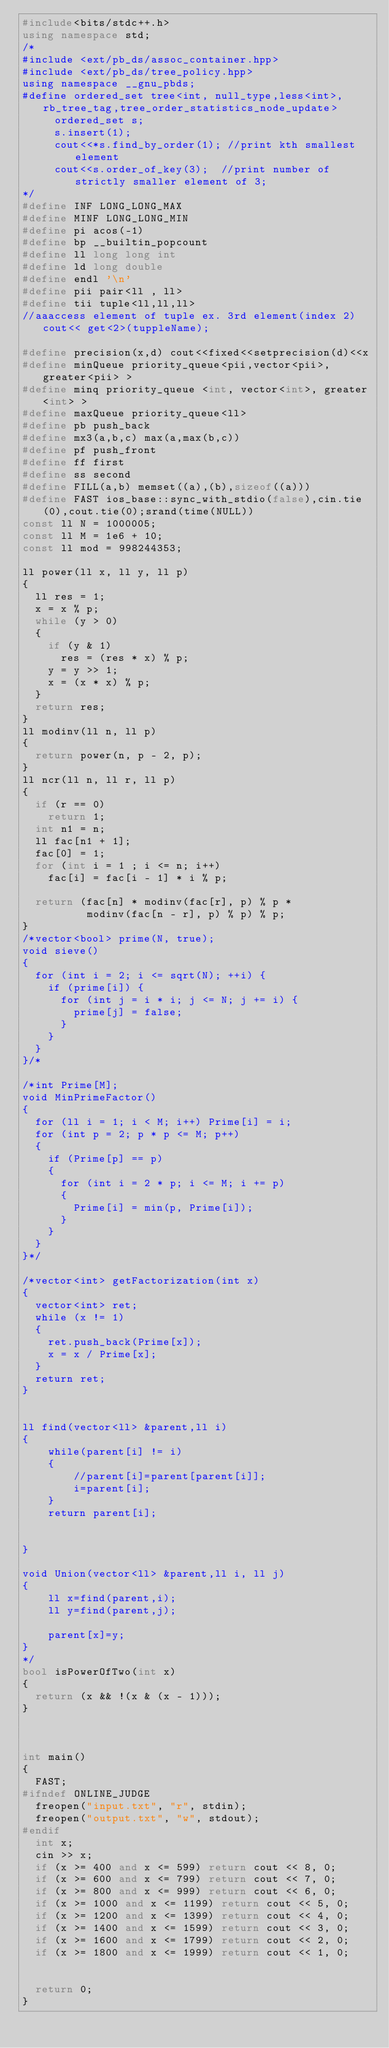Convert code to text. <code><loc_0><loc_0><loc_500><loc_500><_C++_>#include<bits/stdc++.h>
using namespace std;
/*
#include <ext/pb_ds/assoc_container.hpp>
#include <ext/pb_ds/tree_policy.hpp>
using namespace __gnu_pbds;
#define ordered_set tree<int, null_type,less<int>, rb_tree_tag,tree_order_statistics_node_update>
     ordered_set s;
     s.insert(1);
     cout<<*s.find_by_order(1); //print kth smallest element
     cout<<s.order_of_key(3);  //print number of strictly smaller element of 3;
*/
#define INF LONG_LONG_MAX
#define MINF LONG_LONG_MIN
#define pi acos(-1)
#define bp __builtin_popcount
#define ll long long int
#define ld long double
#define endl '\n'
#define pii pair<ll , ll>
#define tii tuple<ll,ll,ll>
//aaaccess element of tuple ex. 3rd element(index 2) cout<< get<2>(tuppleName);

#define precision(x,d) cout<<fixed<<setprecision(d)<<x
#define minQueue priority_queue<pii,vector<pii>,greater<pii> >
#define minq priority_queue <int, vector<int>, greater<int> >
#define maxQueue priority_queue<ll>
#define pb push_back
#define mx3(a,b,c) max(a,max(b,c))
#define pf push_front
#define ff first
#define ss second
#define FILL(a,b) memset((a),(b),sizeof((a)))
#define FAST ios_base::sync_with_stdio(false),cin.tie(0),cout.tie(0);srand(time(NULL))
const ll N = 1000005;
const ll M = 1e6 + 10;
const ll mod = 998244353;

ll power(ll x, ll y, ll p)
{
	ll res = 1;
	x = x % p;
	while (y > 0)
	{
		if (y & 1)
			res = (res * x) % p;
		y = y >> 1;
		x = (x * x) % p;
	}
	return res;
}
ll modinv(ll n, ll p)
{
	return power(n, p - 2, p);
}
ll ncr(ll n, ll r, ll p)
{
	if (r == 0)
		return 1;
	int n1 = n;
	ll fac[n1 + 1];
	fac[0] = 1;
	for (int i = 1 ; i <= n; i++)
		fac[i] = fac[i - 1] * i % p;

	return (fac[n] * modinv(fac[r], p) % p *
	        modinv(fac[n - r], p) % p) % p;
}
/*vector<bool> prime(N, true);
void sieve()
{
	for (int i = 2; i <= sqrt(N); ++i) {
		if (prime[i]) {
			for (int j = i * i; j <= N; j += i) {
				prime[j] = false;
			}
		}
	}
}/*

/*int Prime[M];
void MinPrimeFactor()
{
	for (ll i = 1; i < M; i++) Prime[i] = i;
	for (int p = 2; p * p <= M; p++)
	{
		if (Prime[p] == p)
		{
			for (int i = 2 * p; i <= M; i += p)
			{
				Prime[i] = min(p, Prime[i]);
			}
		}
	}
}*/

/*vector<int> getFactorization(int x)
{
	vector<int> ret;
	while (x != 1)
	{
		ret.push_back(Prime[x]);
		x = x / Prime[x];
	}
	return ret;
}


ll find(vector<ll> &parent,ll i)
{
    while(parent[i] != i)
    {
        //parent[i]=parent[parent[i]];
        i=parent[i];
    }
    return parent[i];


}

void Union(vector<ll> &parent,ll i, ll j)
{
    ll x=find(parent,i);
    ll y=find(parent,j);

    parent[x]=y;
}
*/
bool isPowerOfTwo(int x)
{
	return (x && !(x & (x - 1)));
}



int main()
{
	FAST;
#ifndef ONLINE_JUDGE
	freopen("input.txt", "r", stdin);
	freopen("output.txt", "w", stdout);
#endif
	int x;
	cin >> x;
	if (x >= 400 and x <= 599) return cout << 8, 0;
	if (x >= 600 and x <= 799) return cout << 7, 0;
	if (x >= 800 and x <= 999) return cout << 6, 0;
	if (x >= 1000 and x <= 1199) return cout << 5, 0;
	if (x >= 1200 and x <= 1399) return cout << 4, 0;
	if (x >= 1400 and x <= 1599) return cout << 3, 0;
	if (x >= 1600 and x <= 1799) return cout << 2, 0;
	if (x >= 1800 and x <= 1999) return cout << 1, 0;


	return 0;
}
</code> 